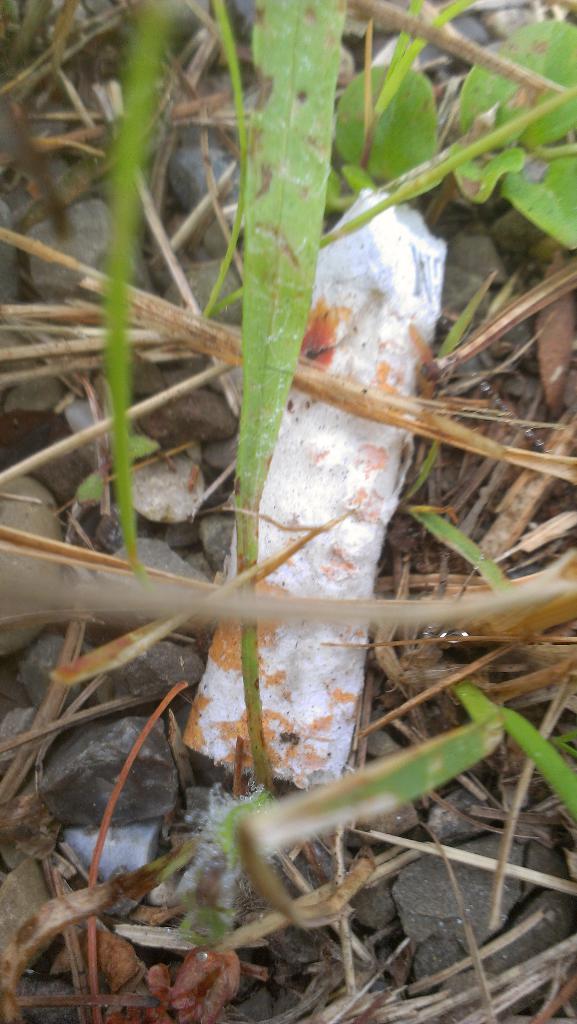How would you summarize this image in a sentence or two? In this image I can see grass, stones and a white color object. 